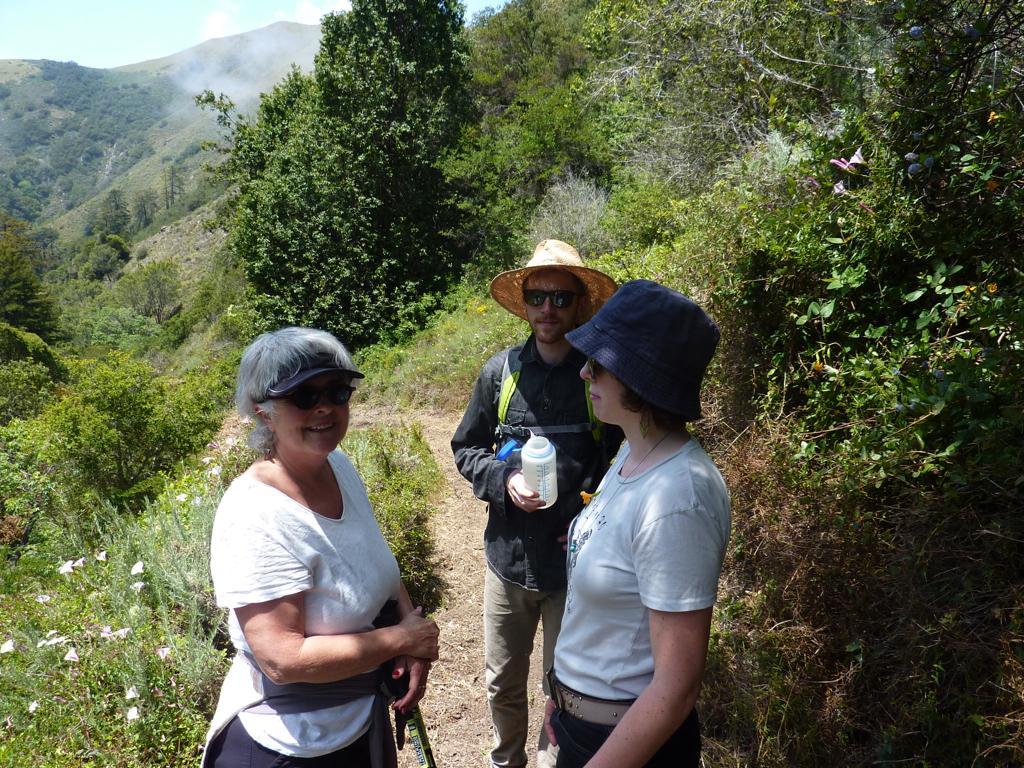Can you describe this image briefly? In the middle bottom, there are three persons standing. One is wearing goggle and both are wearing a hat. This person is holding a bottle in his hand. And both side of the image, there are trees covered on the mountain. In the top left, sky is visible which is blue in color. This image is taken during day time on the mountain. 